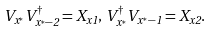<formula> <loc_0><loc_0><loc_500><loc_500>V _ { x ^ { \ast } } V ^ { \dagger } _ { x ^ { \ast } - 2 } = X _ { x 1 } , \, V ^ { \dagger } _ { x ^ { \ast } } V _ { x ^ { \ast } - 1 } = X _ { x 2 } .</formula> 